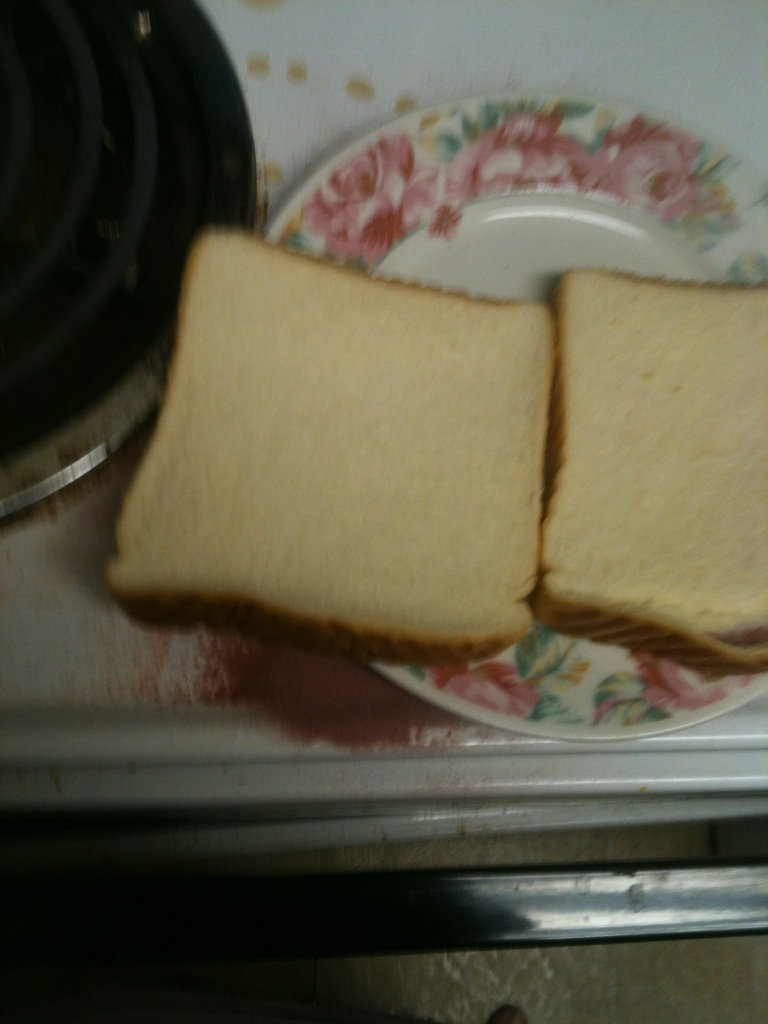Are you able to tell if there is any mold on the bread? From the image provided, there appears to be no visible mold on the slices of bread. The edges and surfaces are consistent in color and texture, suggesting they are fresh. However, for complete certainty, it's recommended to inspect the bread under proper lighting and from multiple angles, as mold can sometimes be hard to detect in photographs. 